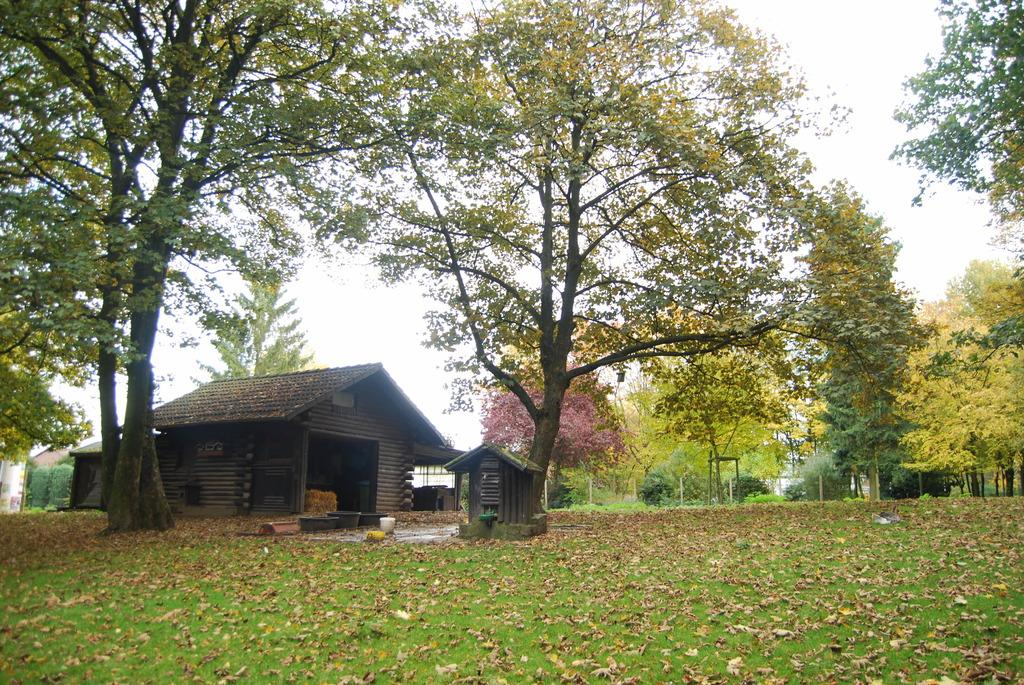What type of structure is visible in the image? There is a house in the image. What colors are used for the house? The house is in brown and black colors. What type of vegetation can be seen in the image? There are trees in the image. What type of barrier is present in the image? There is fencing in the image. What objects are present near the house? There are tubs in the image. What is the color of the sky in the image? The sky is white in color. What type of lip can be seen on the house in the image? There is no lip present on the house in the image. What type of pan is visible in the image? There is no pan visible in the image. 